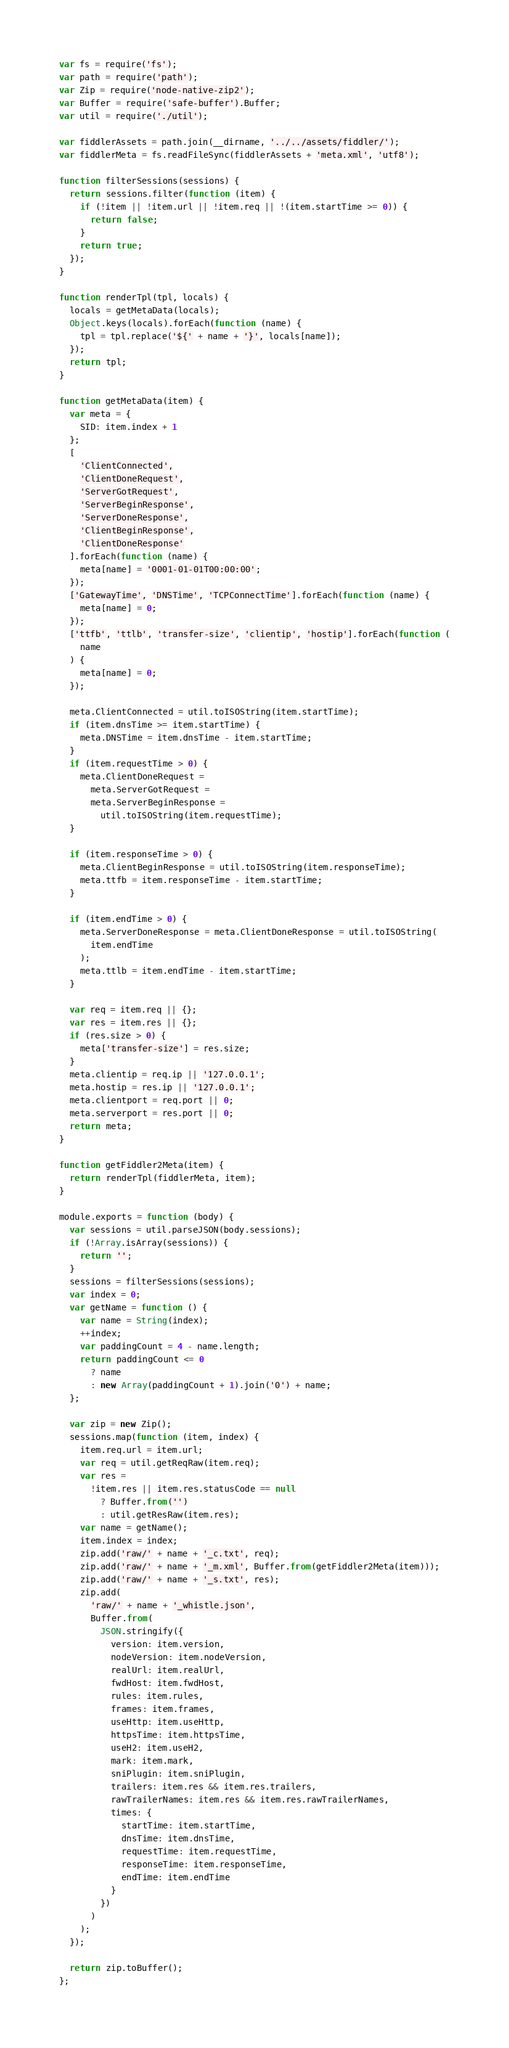Convert code to text. <code><loc_0><loc_0><loc_500><loc_500><_JavaScript_>var fs = require('fs');
var path = require('path');
var Zip = require('node-native-zip2');
var Buffer = require('safe-buffer').Buffer;
var util = require('./util');

var fiddlerAssets = path.join(__dirname, '../../assets/fiddler/');
var fiddlerMeta = fs.readFileSync(fiddlerAssets + 'meta.xml', 'utf8');

function filterSessions(sessions) {
  return sessions.filter(function (item) {
    if (!item || !item.url || !item.req || !(item.startTime >= 0)) {
      return false;
    }
    return true;
  });
}

function renderTpl(tpl, locals) {
  locals = getMetaData(locals);
  Object.keys(locals).forEach(function (name) {
    tpl = tpl.replace('${' + name + '}', locals[name]);
  });
  return tpl;
}

function getMetaData(item) {
  var meta = {
    SID: item.index + 1
  };
  [
    'ClientConnected',
    'ClientDoneRequest',
    'ServerGotRequest',
    'ServerBeginResponse',
    'ServerDoneResponse',
    'ClientBeginResponse',
    'ClientDoneResponse'
  ].forEach(function (name) {
    meta[name] = '0001-01-01T00:00:00';
  });
  ['GatewayTime', 'DNSTime', 'TCPConnectTime'].forEach(function (name) {
    meta[name] = 0;
  });
  ['ttfb', 'ttlb', 'transfer-size', 'clientip', 'hostip'].forEach(function (
    name
  ) {
    meta[name] = 0;
  });

  meta.ClientConnected = util.toISOString(item.startTime);
  if (item.dnsTime >= item.startTime) {
    meta.DNSTime = item.dnsTime - item.startTime;
  }
  if (item.requestTime > 0) {
    meta.ClientDoneRequest =
      meta.ServerGotRequest =
      meta.ServerBeginResponse =
        util.toISOString(item.requestTime);
  }

  if (item.responseTime > 0) {
    meta.ClientBeginResponse = util.toISOString(item.responseTime);
    meta.ttfb = item.responseTime - item.startTime;
  }

  if (item.endTime > 0) {
    meta.ServerDoneResponse = meta.ClientDoneResponse = util.toISOString(
      item.endTime
    );
    meta.ttlb = item.endTime - item.startTime;
  }

  var req = item.req || {};
  var res = item.res || {};
  if (res.size > 0) {
    meta['transfer-size'] = res.size;
  }
  meta.clientip = req.ip || '127.0.0.1';
  meta.hostip = res.ip || '127.0.0.1';
  meta.clientport = req.port || 0;
  meta.serverport = res.port || 0;
  return meta;
}

function getFiddler2Meta(item) {
  return renderTpl(fiddlerMeta, item);
}

module.exports = function (body) {
  var sessions = util.parseJSON(body.sessions);
  if (!Array.isArray(sessions)) {
    return '';
  }
  sessions = filterSessions(sessions);
  var index = 0;
  var getName = function () {
    var name = String(index);
    ++index;
    var paddingCount = 4 - name.length;
    return paddingCount <= 0
      ? name
      : new Array(paddingCount + 1).join('0') + name;
  };

  var zip = new Zip();
  sessions.map(function (item, index) {
    item.req.url = item.url;
    var req = util.getReqRaw(item.req);
    var res =
      !item.res || item.res.statusCode == null
        ? Buffer.from('')
        : util.getResRaw(item.res);
    var name = getName();
    item.index = index;
    zip.add('raw/' + name + '_c.txt', req);
    zip.add('raw/' + name + '_m.xml', Buffer.from(getFiddler2Meta(item)));
    zip.add('raw/' + name + '_s.txt', res);
    zip.add(
      'raw/' + name + '_whistle.json',
      Buffer.from(
        JSON.stringify({
          version: item.version,
          nodeVersion: item.nodeVersion,
          realUrl: item.realUrl,
          fwdHost: item.fwdHost,
          rules: item.rules,
          frames: item.frames,
          useHttp: item.useHttp,
          httpsTime: item.httpsTime,
          useH2: item.useH2,
          mark: item.mark,
          sniPlugin: item.sniPlugin,
          trailers: item.res && item.res.trailers,
          rawTrailerNames: item.res && item.res.rawTrailerNames,
          times: {
            startTime: item.startTime,
            dnsTime: item.dnsTime,
            requestTime: item.requestTime,
            responseTime: item.responseTime,
            endTime: item.endTime
          }
        })
      )
    );
  });

  return zip.toBuffer();
};
</code> 